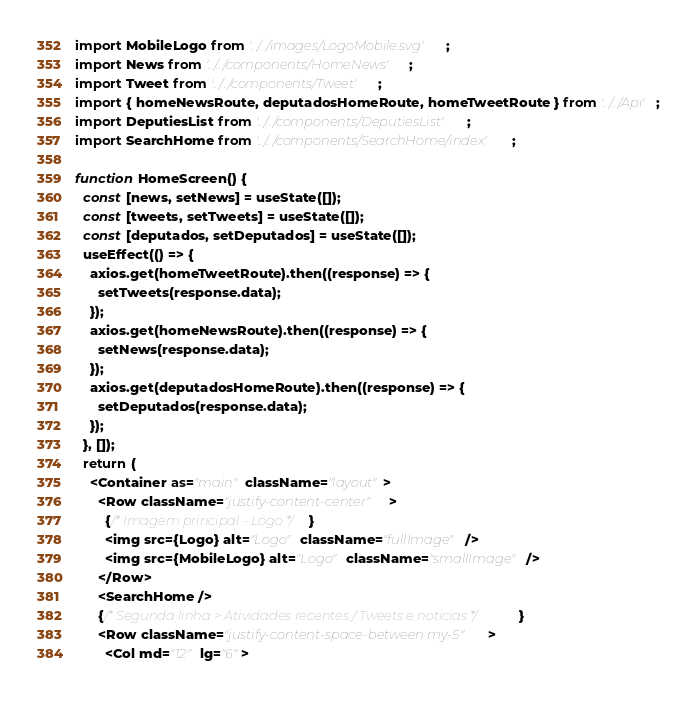<code> <loc_0><loc_0><loc_500><loc_500><_JavaScript_>import MobileLogo from '../../images/LogoMobile.svg';
import News from '../../components/HomeNews';
import Tweet from '../../components/Tweet';
import { homeNewsRoute, deputadosHomeRoute, homeTweetRoute } from '../../Api';
import DeputiesList from '../../components/DeputiesList';
import SearchHome from '../../components/SearchHome/index';

function HomeScreen() {
  const [news, setNews] = useState([]);
  const [tweets, setTweets] = useState([]);
  const [deputados, setDeputados] = useState([]);
  useEffect(() => {
    axios.get(homeTweetRoute).then((response) => {
      setTweets(response.data);
    });
    axios.get(homeNewsRoute).then((response) => {
      setNews(response.data);
    });
    axios.get(deputadosHomeRoute).then((response) => {
      setDeputados(response.data);
    });
  }, []);
  return (
    <Container as="main" className="layout">
      <Row className="justify-content-center">
        {/* Imagem principal - Logo */}
        <img src={Logo} alt="Logo" className="fullImage" />
        <img src={MobileLogo} alt="Logo" className="smallImage" />
      </Row>
      <SearchHome />
      {/* Segunda linha > Atividades recentes / Tweets e noticias */}
      <Row className="justify-content-space-between my-5">
        <Col md="12" lg="6"></code> 